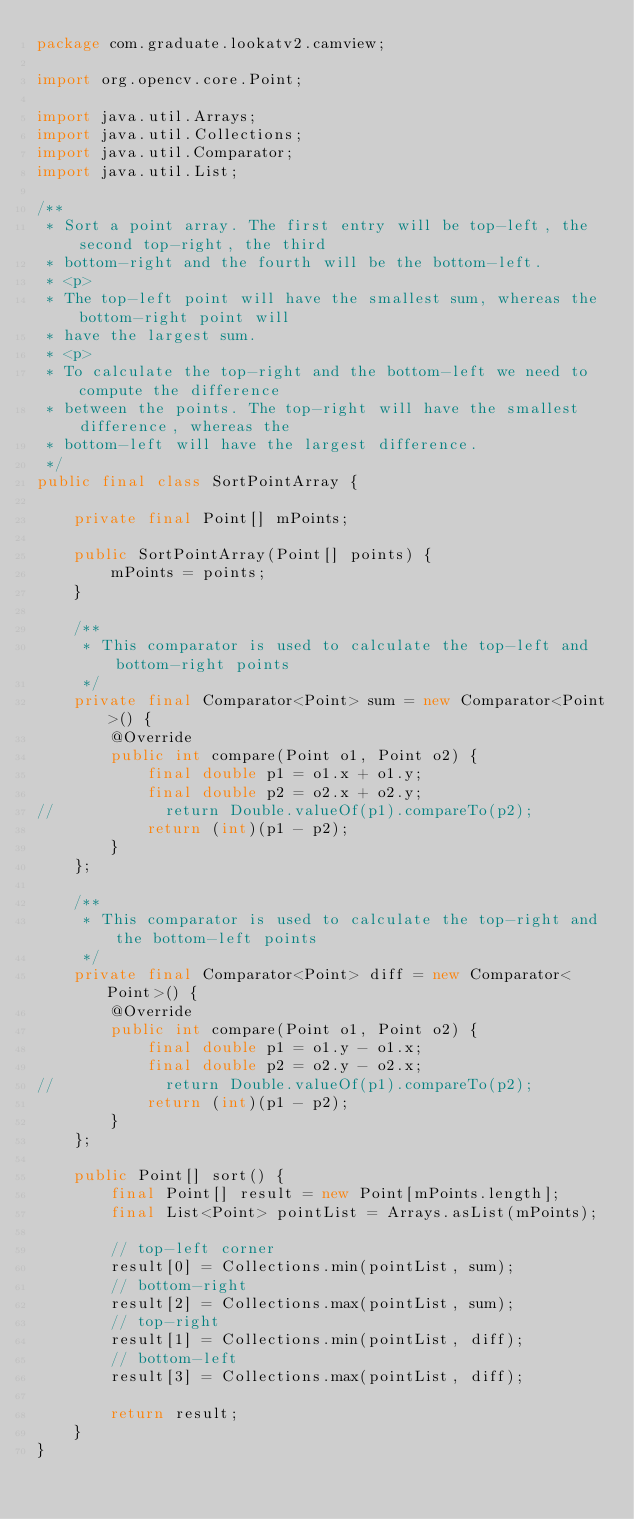<code> <loc_0><loc_0><loc_500><loc_500><_Java_>package com.graduate.lookatv2.camview;

import org.opencv.core.Point;

import java.util.Arrays;
import java.util.Collections;
import java.util.Comparator;
import java.util.List;

/**
 * Sort a point array. The first entry will be top-left, the second top-right, the third
 * bottom-right and the fourth will be the bottom-left.
 * <p>
 * The top-left point will have the smallest sum, whereas the bottom-right point will
 * have the largest sum.
 * <p>
 * To calculate the top-right and the bottom-left we need to compute the difference
 * between the points. The top-right will have the smallest difference, whereas the
 * bottom-left will have the largest difference.
 */
public final class SortPointArray {

    private final Point[] mPoints;

    public SortPointArray(Point[] points) {
        mPoints = points;
    }

    /**
     * This comparator is used to calculate the top-left and bottom-right points
     */
    private final Comparator<Point> sum = new Comparator<Point>() {
        @Override
        public int compare(Point o1, Point o2) {
            final double p1 = o1.x + o1.y;
            final double p2 = o2.x + o2.y;
//            return Double.valueOf(p1).compareTo(p2);
            return (int)(p1 - p2);
        }
    };

    /**
     * This comparator is used to calculate the top-right and the bottom-left points
     */
    private final Comparator<Point> diff = new Comparator<Point>() {
        @Override
        public int compare(Point o1, Point o2) {
            final double p1 = o1.y - o1.x;
            final double p2 = o2.y - o2.x;
//            return Double.valueOf(p1).compareTo(p2);
            return (int)(p1 - p2);
        }
    };

    public Point[] sort() {
        final Point[] result = new Point[mPoints.length];
        final List<Point> pointList = Arrays.asList(mPoints);

        // top-left corner
        result[0] = Collections.min(pointList, sum);
        // bottom-right
        result[2] = Collections.max(pointList, sum);
        // top-right
        result[1] = Collections.min(pointList, diff);
        // bottom-left
        result[3] = Collections.max(pointList, diff);

        return result;
    }
}</code> 